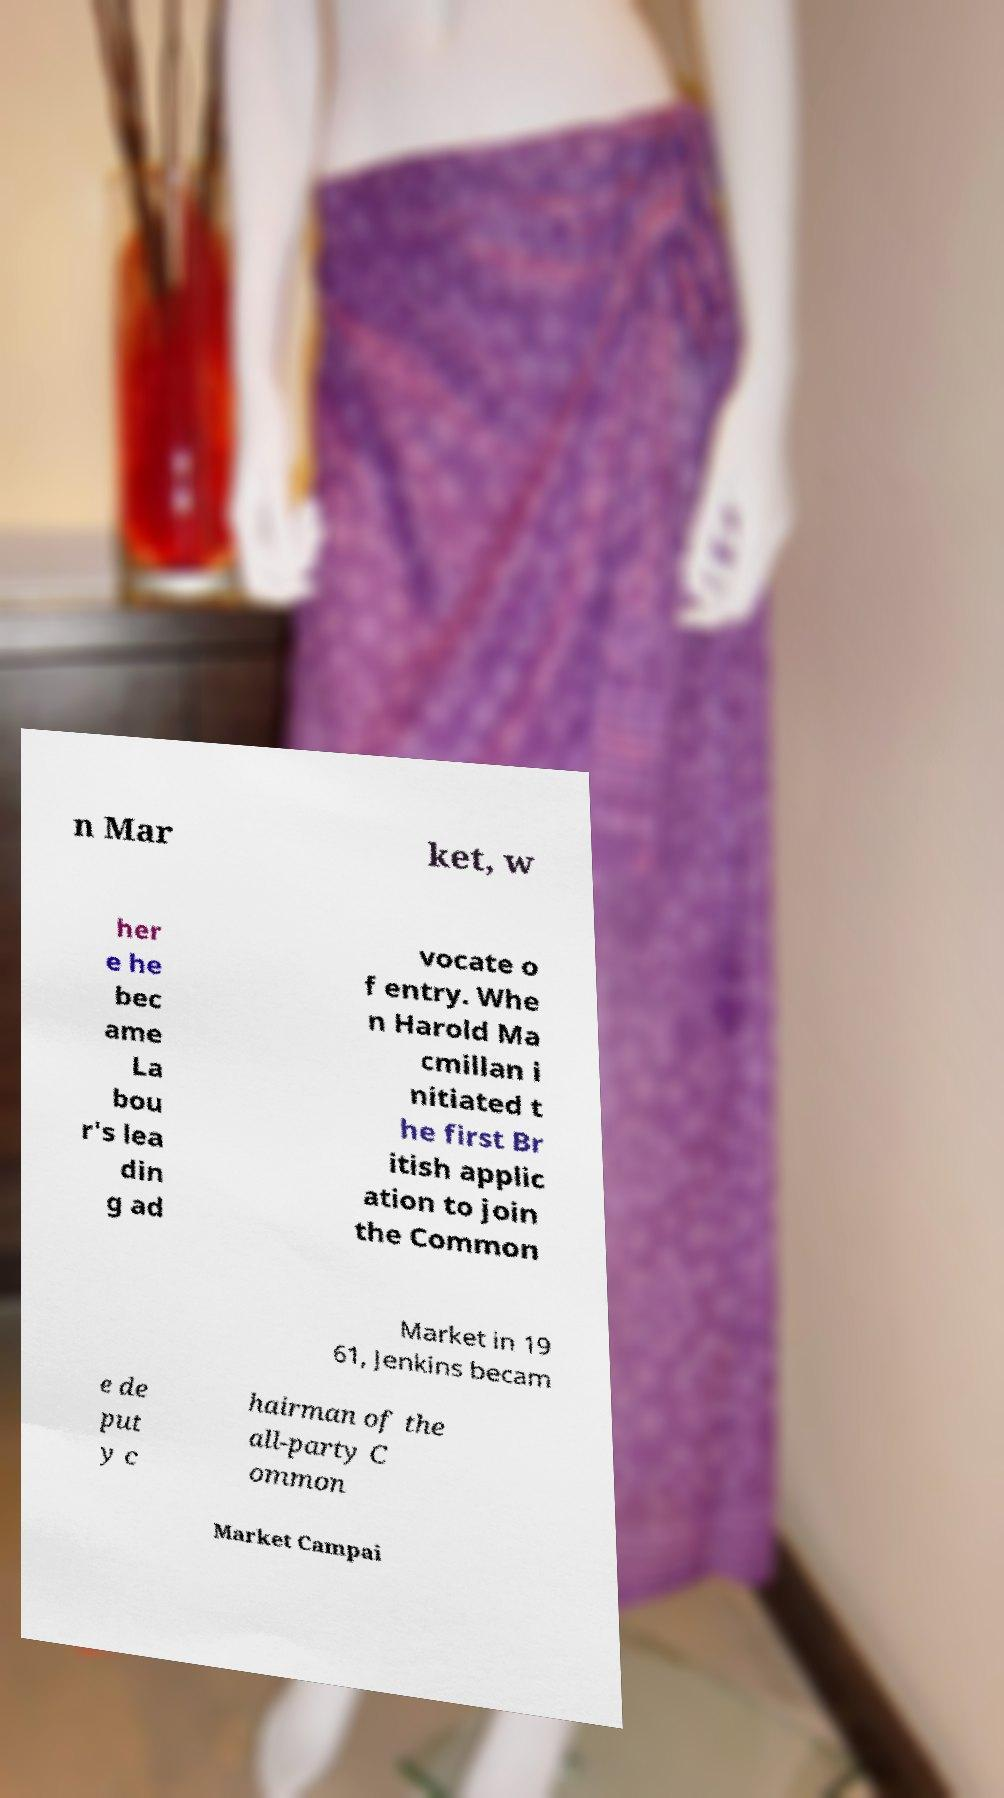Please identify and transcribe the text found in this image. n Mar ket, w her e he bec ame La bou r's lea din g ad vocate o f entry. Whe n Harold Ma cmillan i nitiated t he first Br itish applic ation to join the Common Market in 19 61, Jenkins becam e de put y c hairman of the all-party C ommon Market Campai 